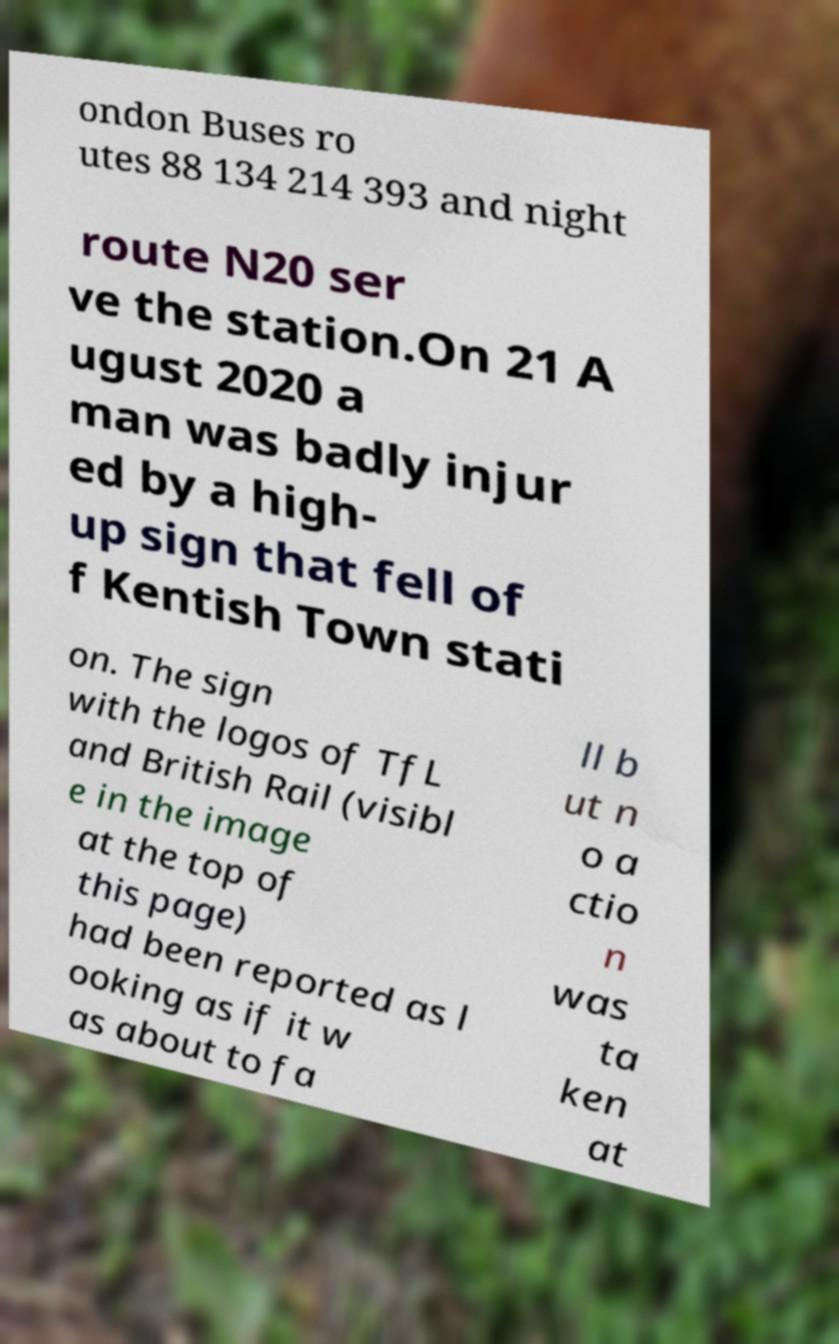I need the written content from this picture converted into text. Can you do that? ondon Buses ro utes 88 134 214 393 and night route N20 ser ve the station.On 21 A ugust 2020 a man was badly injur ed by a high- up sign that fell of f Kentish Town stati on. The sign with the logos of TfL and British Rail (visibl e in the image at the top of this page) had been reported as l ooking as if it w as about to fa ll b ut n o a ctio n was ta ken at 